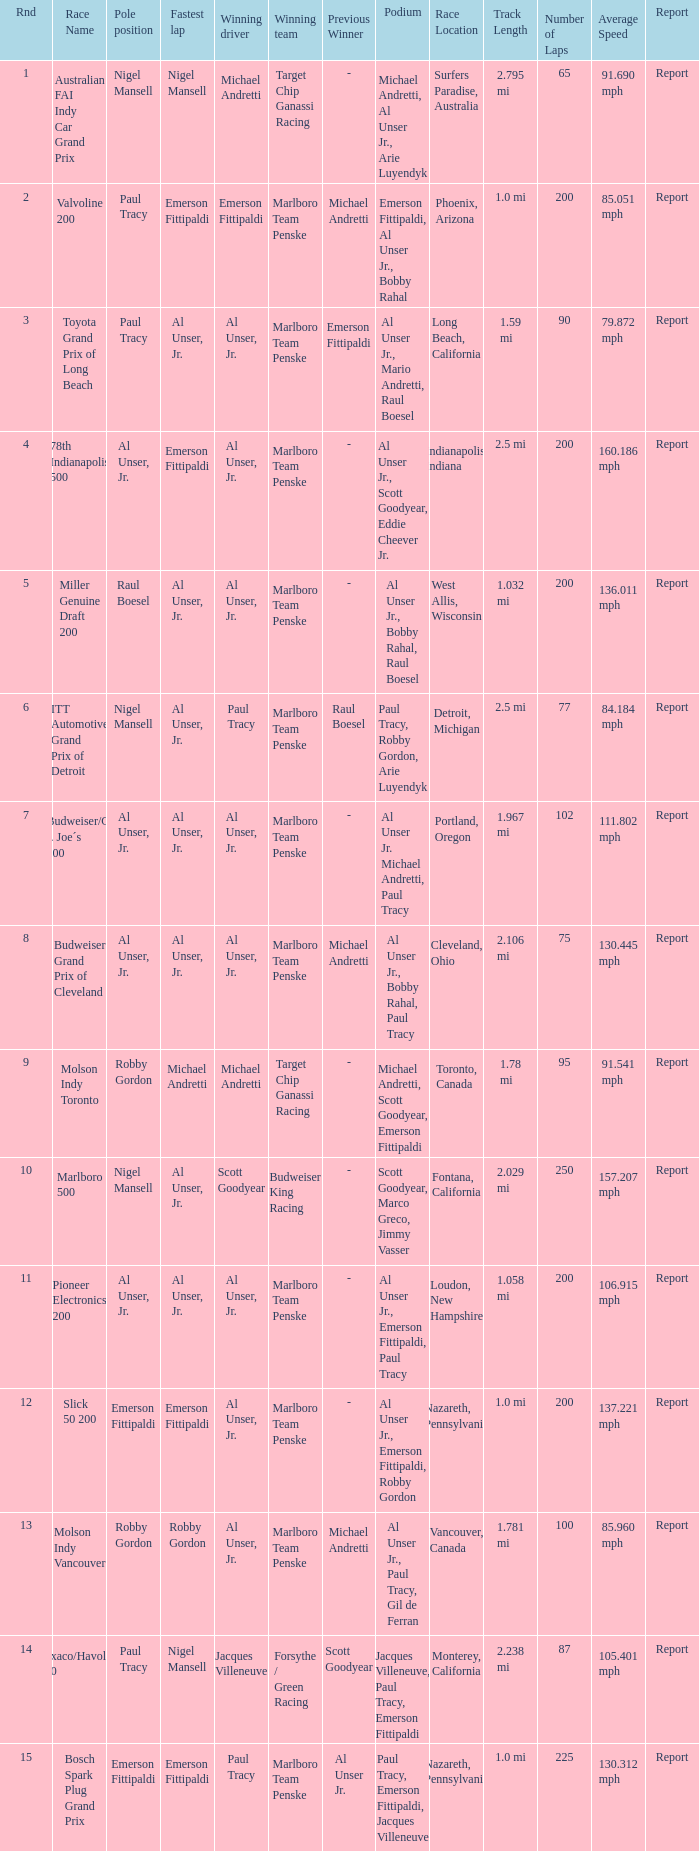Who did the fastest lap in the race won by Paul Tracy, with Emerson Fittipaldi at the pole position? Emerson Fittipaldi. 